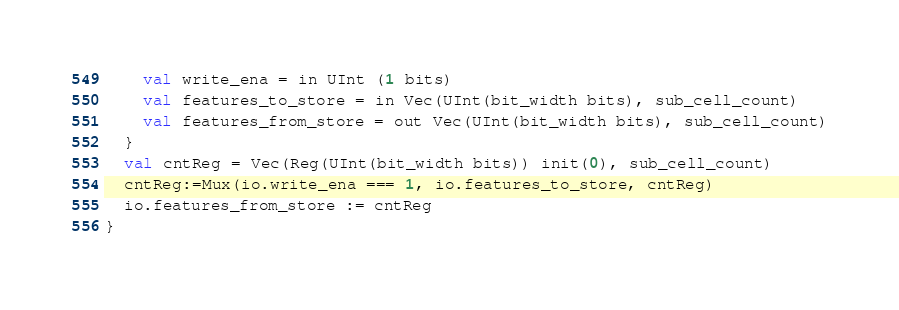Convert code to text. <code><loc_0><loc_0><loc_500><loc_500><_Scala_>    val write_ena = in UInt (1 bits)
    val features_to_store = in Vec(UInt(bit_width bits), sub_cell_count)
    val features_from_store = out Vec(UInt(bit_width bits), sub_cell_count)
  }
  val cntReg = Vec(Reg(UInt(bit_width bits)) init(0), sub_cell_count)
  cntReg:=Mux(io.write_ena === 1, io.features_to_store, cntReg)
  io.features_from_store := cntReg
}

</code> 